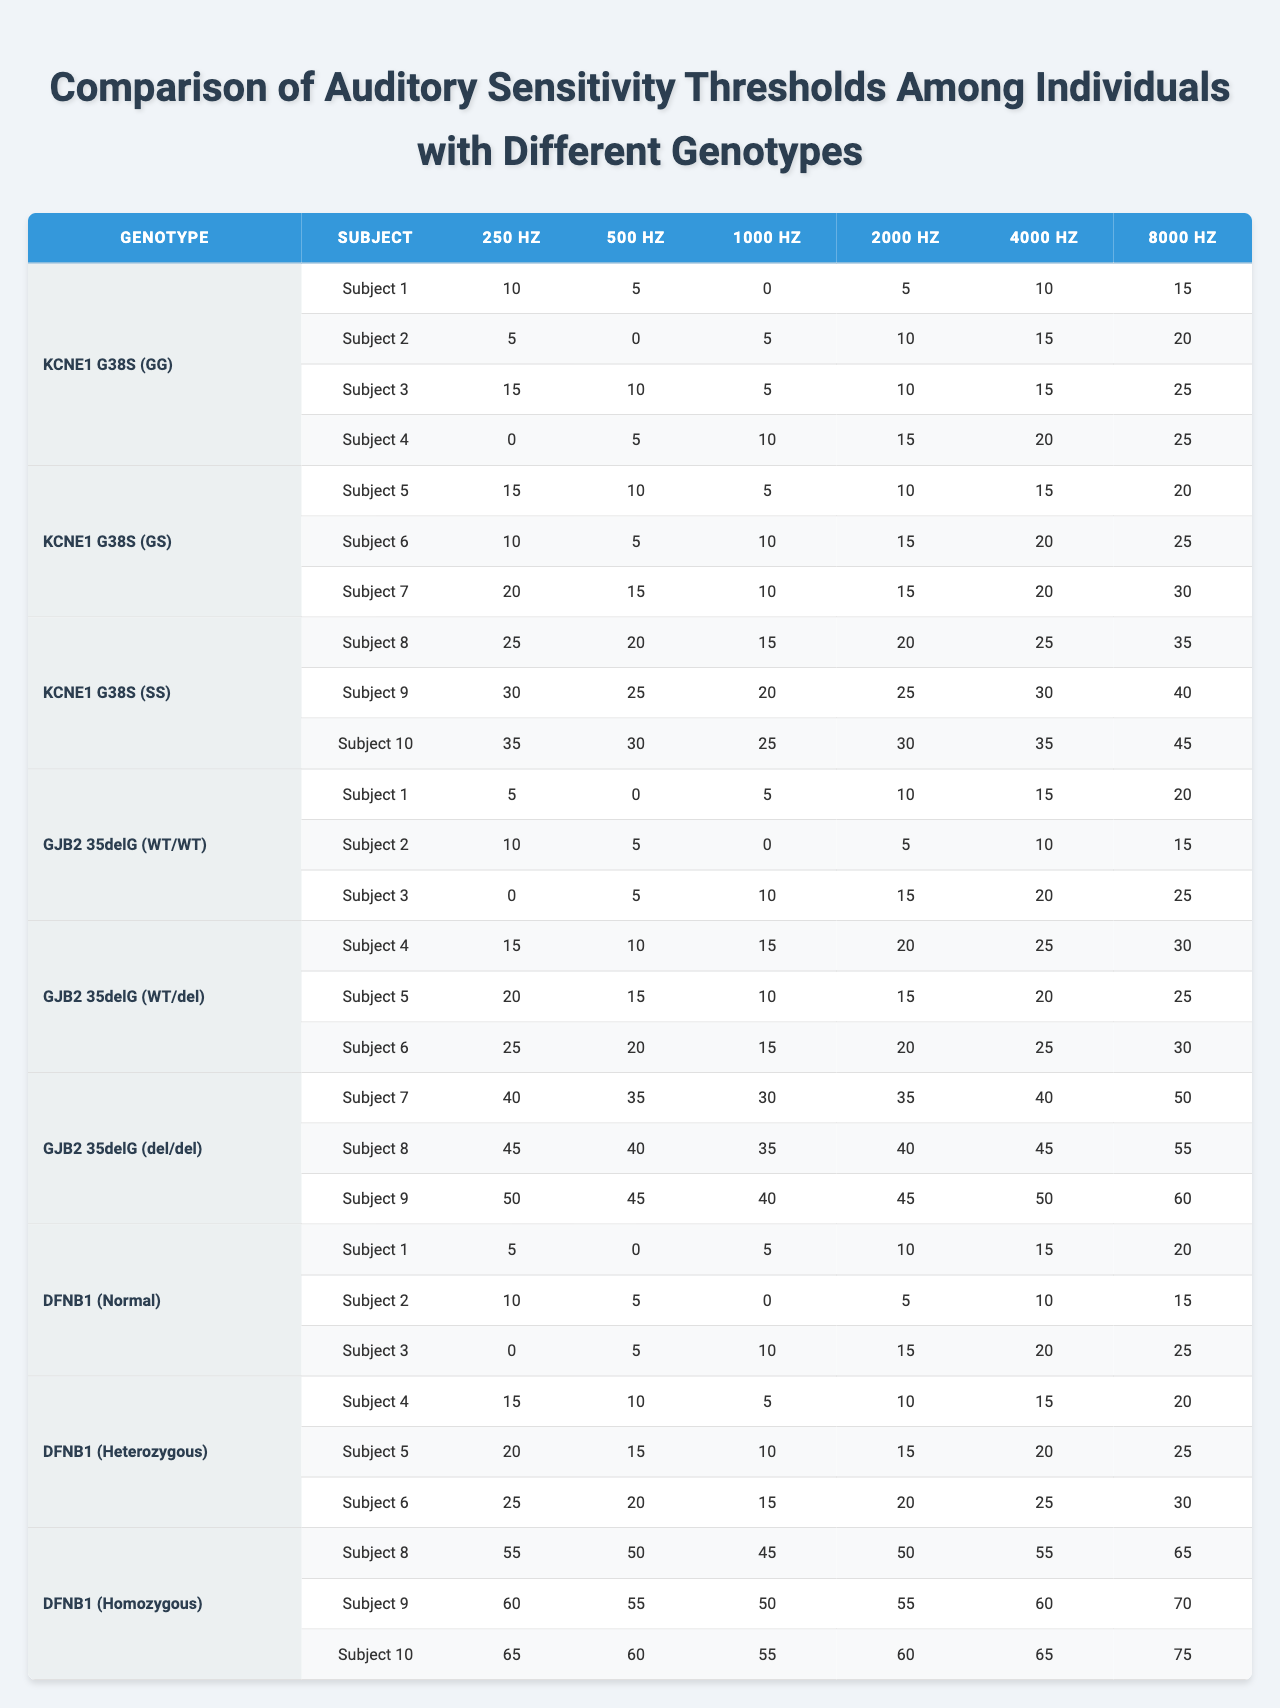What is the auditory threshold for Subject 1 under the genotype KCNE1 G38S (GG) at 2000 Hz? Looking at the table, Subject 1 under KCNE1 G38S (GG) has an auditory threshold of 5 at 2000 Hz.
Answer: 5 What genotype has the highest auditory threshold at 8000 Hz? To find this, we look at the auditory thresholds for all genotypes at 8000 Hz. The highest value is 75 for Subject 10 under the genotype DFNB1 (Homozygous).
Answer: DFNB1 (Homozygous) Which genotype shows the lowest auditory thresholds at 500 Hz across all subjects? Reviewing the table, the lowest auditory threshold at 500 Hz is 0 for multiple subjects under KCNE1 G38S (GG) and GJB2 35delG (WT/WT). However, KCNE1 G38S (GG) has more subjects showing this value.
Answer: KCNE1 G38S (GG) and GJB2 35delG (WT/WT) What is the average auditory threshold for Subject 3 across all genotypes? For Subject 3, we gather the thresholds: KCNE1 G38S (GG) = 5, GJB2 35delG (WT/WT) = 10, KCNE1 G38S (GS) = 5, DFNB1 (Normal) = 10, GJB2 35delG (del/del) is not present. We take only the available values and calculate the average as (5 + 10 + 5 + 10) / 4 = 7.5.
Answer: 7.5 Is there any subject with the same auditory threshold at 1000 Hz under different genotypes? Inspecting the table for 1000 Hz, Subject 1 has thresholds of 5 (KCNE1 G38S (GG) and GJB2 35delG (WT/WT)), but these genotypes are not the same. Therefore, yes, there are duplicates.
Answer: Yes Which genotype shows the most improvement in auditory thresholds from lower to higher frequencies for Subject 5? Analyzing Subject 5’s auditory thresholds: at 250 Hz = 20, 500 Hz = 15, 1000 Hz = 10, 2000 Hz = 15, 4000 Hz = 20, and 8000 Hz = 25. The values fluctuate but show a general increase from 250 Hz to 4000 Hz and peak at 8000 Hz, indicating considerable improvement.
Answer: Significant improvement What is the difference in auditory thresholds for Subject 9 between 250 Hz and 8000 Hz under KCNE1 G38S (SS)? Subject 9 under KCNE1 G38S (SS) has an auditory threshold of 30 at 8000 Hz and 30 at 250 Hz. The difference is 30 - 30 = 0.
Answer: 0 Who has a higher auditory threshold at 4000 Hz, Subject 2 under GJB2 35delG (del/del) or Subject 1 under DFNB1 (Heterozygous)? Subject 2 under GJB2 35delG (del/del) is not present, we cannot compare. Subject 1 under DFNB1 (Heterozygous) has a threshold of 15 which is the only reference and thus stands alone.
Answer: Subject 1 has a threshold of 15 Are auditory thresholds consistently lower for KCNE1 G38S (GG) than for DFNB1 (Normal) at all frequencies? Cross-referencing both genotypes across all frequencies shows that KCNE1 G38S (GG) has lower thresholds at (10, 5, 0, 5, 10, 15) compared to DFNB1 (Normal) which has (5, 0, 5, 10, 15, 20) for the respective frequencies. The comparison shows inconsistency at 8000 Hz where KCNE1 G38S (GG) exceeds the value of DFNB1 (Normal).
Answer: No What is the maximum auditory threshold observed across all subjects at 250 Hz? At 250 Hz, reviewing the thresholds across all subjects reveals the maximum of 55 for Subject 8 under DFNB1 (Homozygous), which is the highest.
Answer: 55 